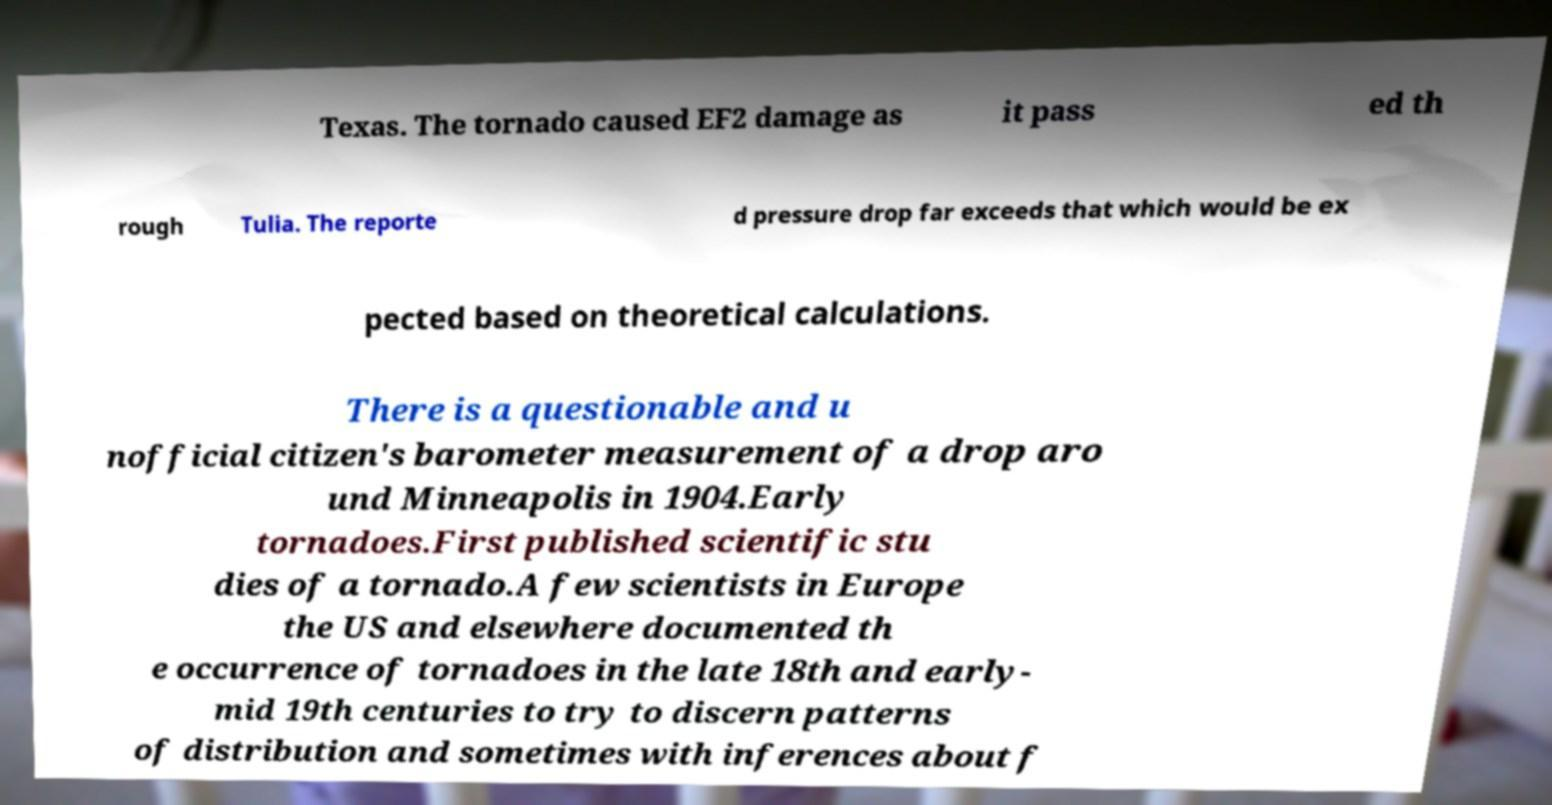I need the written content from this picture converted into text. Can you do that? Texas. The tornado caused EF2 damage as it pass ed th rough Tulia. The reporte d pressure drop far exceeds that which would be ex pected based on theoretical calculations. There is a questionable and u nofficial citizen's barometer measurement of a drop aro und Minneapolis in 1904.Early tornadoes.First published scientific stu dies of a tornado.A few scientists in Europe the US and elsewhere documented th e occurrence of tornadoes in the late 18th and early- mid 19th centuries to try to discern patterns of distribution and sometimes with inferences about f 